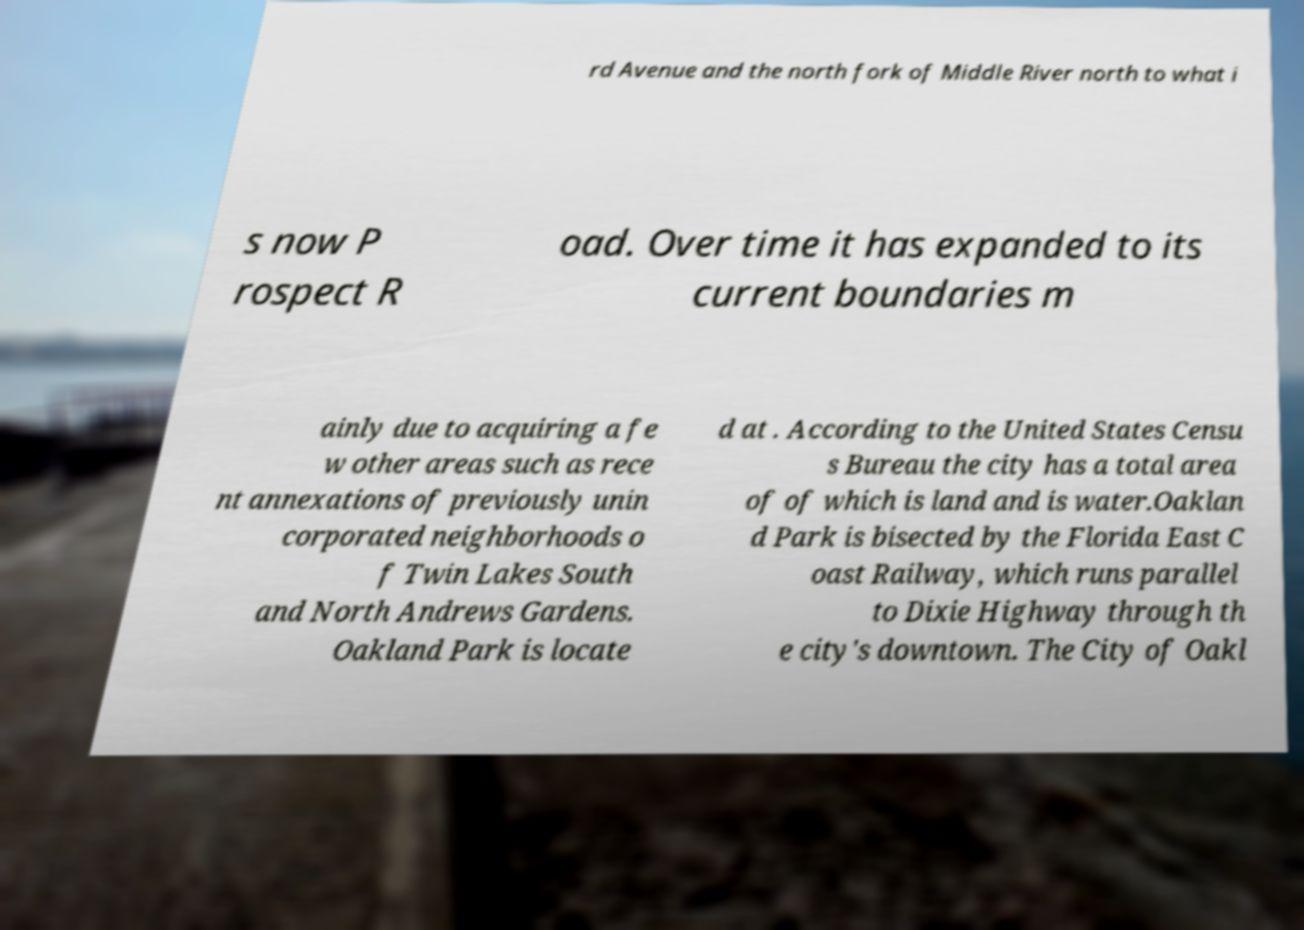Could you extract and type out the text from this image? rd Avenue and the north fork of Middle River north to what i s now P rospect R oad. Over time it has expanded to its current boundaries m ainly due to acquiring a fe w other areas such as rece nt annexations of previously unin corporated neighborhoods o f Twin Lakes South and North Andrews Gardens. Oakland Park is locate d at . According to the United States Censu s Bureau the city has a total area of of which is land and is water.Oaklan d Park is bisected by the Florida East C oast Railway, which runs parallel to Dixie Highway through th e city's downtown. The City of Oakl 